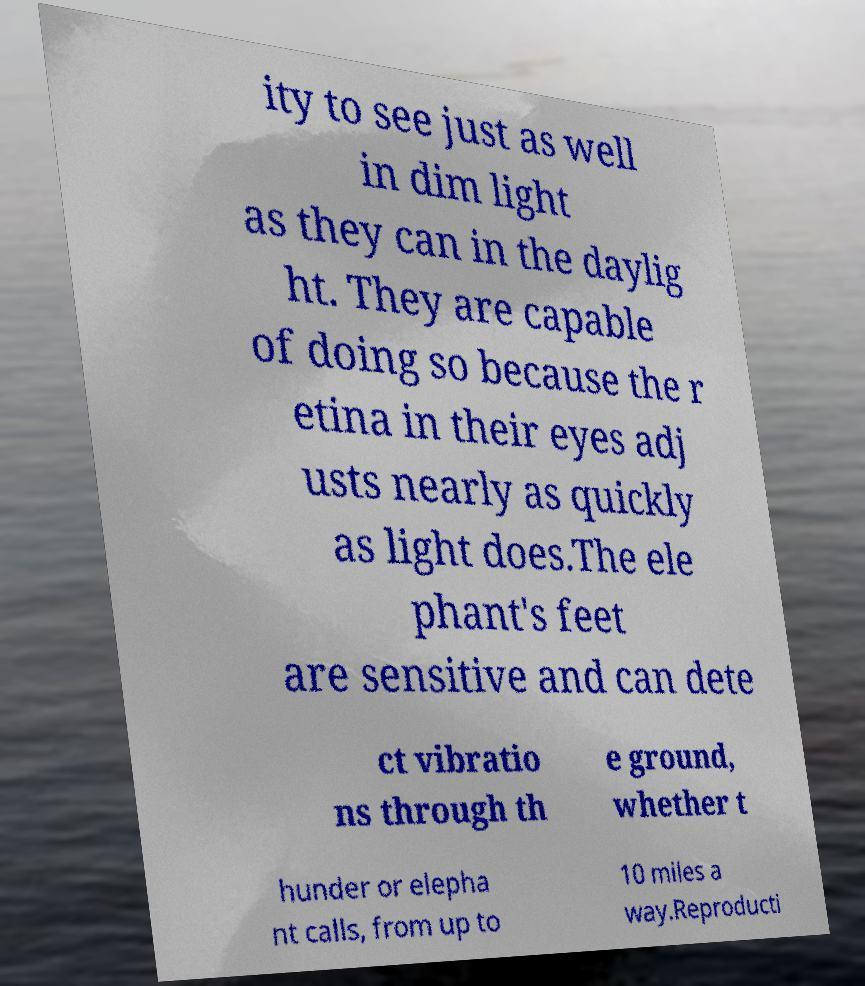Please identify and transcribe the text found in this image. ity to see just as well in dim light as they can in the daylig ht. They are capable of doing so because the r etina in their eyes adj usts nearly as quickly as light does.The ele phant's feet are sensitive and can dete ct vibratio ns through th e ground, whether t hunder or elepha nt calls, from up to 10 miles a way.Reproducti 